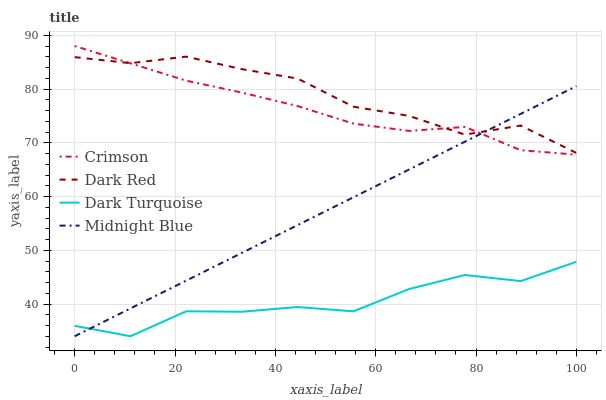Does Dark Turquoise have the minimum area under the curve?
Answer yes or no. Yes. Does Dark Red have the maximum area under the curve?
Answer yes or no. Yes. Does Midnight Blue have the minimum area under the curve?
Answer yes or no. No. Does Midnight Blue have the maximum area under the curve?
Answer yes or no. No. Is Midnight Blue the smoothest?
Answer yes or no. Yes. Is Dark Turquoise the roughest?
Answer yes or no. Yes. Is Dark Red the smoothest?
Answer yes or no. No. Is Dark Red the roughest?
Answer yes or no. No. Does Midnight Blue have the lowest value?
Answer yes or no. Yes. Does Dark Red have the lowest value?
Answer yes or no. No. Does Crimson have the highest value?
Answer yes or no. Yes. Does Dark Red have the highest value?
Answer yes or no. No. Is Dark Turquoise less than Crimson?
Answer yes or no. Yes. Is Dark Red greater than Dark Turquoise?
Answer yes or no. Yes. Does Crimson intersect Midnight Blue?
Answer yes or no. Yes. Is Crimson less than Midnight Blue?
Answer yes or no. No. Is Crimson greater than Midnight Blue?
Answer yes or no. No. Does Dark Turquoise intersect Crimson?
Answer yes or no. No. 